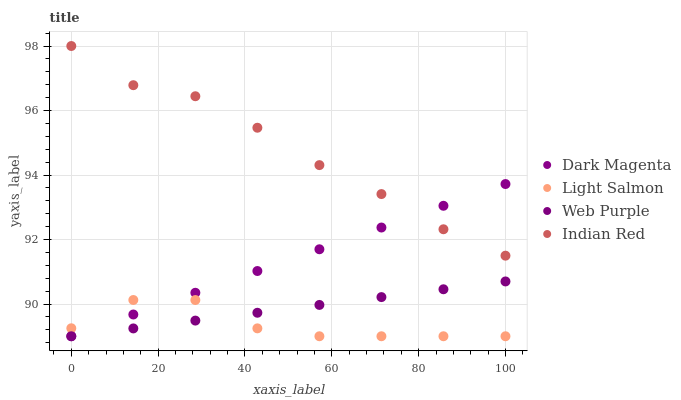Does Light Salmon have the minimum area under the curve?
Answer yes or no. Yes. Does Indian Red have the maximum area under the curve?
Answer yes or no. Yes. Does Dark Magenta have the minimum area under the curve?
Answer yes or no. No. Does Dark Magenta have the maximum area under the curve?
Answer yes or no. No. Is Dark Magenta the smoothest?
Answer yes or no. Yes. Is Light Salmon the roughest?
Answer yes or no. Yes. Is Light Salmon the smoothest?
Answer yes or no. No. Is Dark Magenta the roughest?
Answer yes or no. No. Does Web Purple have the lowest value?
Answer yes or no. Yes. Does Indian Red have the lowest value?
Answer yes or no. No. Does Indian Red have the highest value?
Answer yes or no. Yes. Does Dark Magenta have the highest value?
Answer yes or no. No. Is Web Purple less than Indian Red?
Answer yes or no. Yes. Is Indian Red greater than Web Purple?
Answer yes or no. Yes. Does Dark Magenta intersect Light Salmon?
Answer yes or no. Yes. Is Dark Magenta less than Light Salmon?
Answer yes or no. No. Is Dark Magenta greater than Light Salmon?
Answer yes or no. No. Does Web Purple intersect Indian Red?
Answer yes or no. No. 